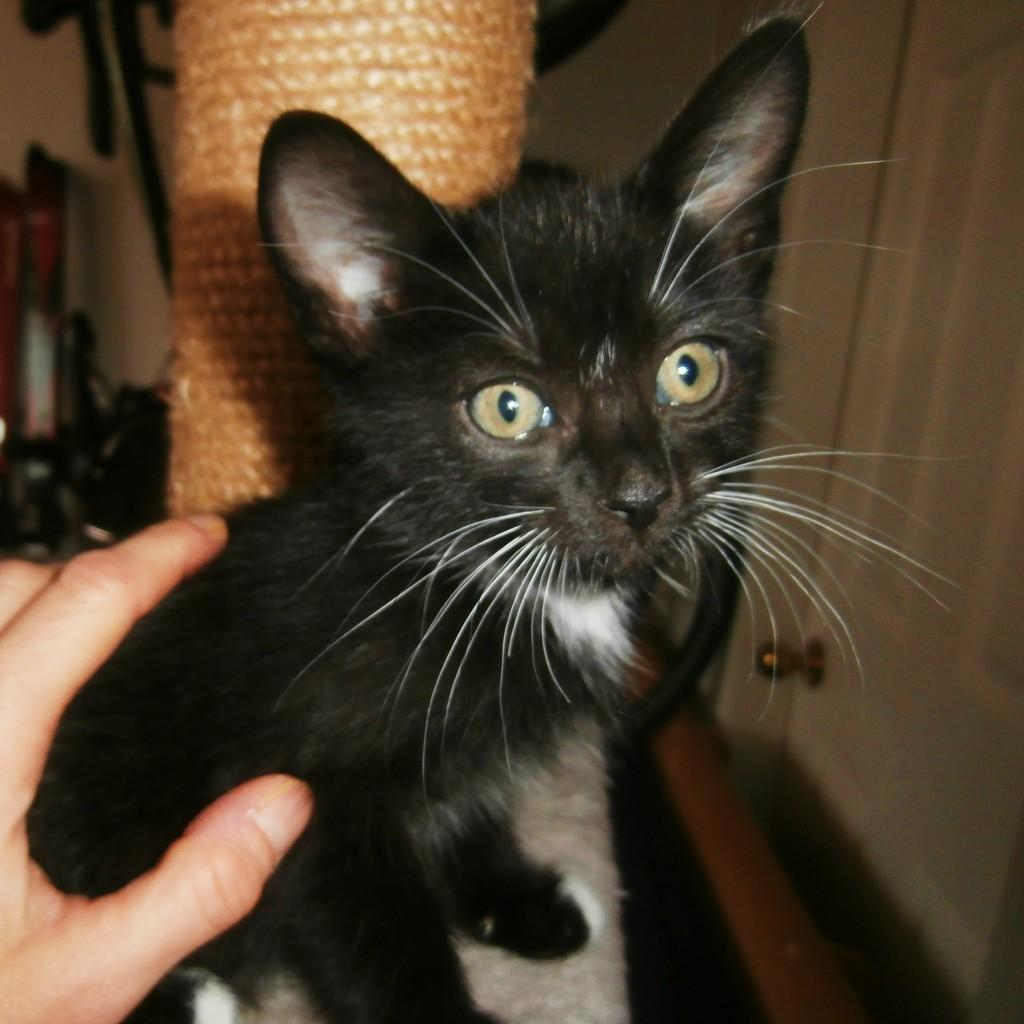What is the main subject in the foreground of the image? There is a cat in the foreground of the image. What else can be seen in the foreground of the image? A person's hand is visible in the foreground of the image. What structures are present in the background of the image? There is a pillar, a wall, and a door in the background of the image. What other objects are present in the background of the image? There are some objects in the background of the image. Can you describe the setting of the image? The image is likely taken in a room. What type of pickle is the cat holding in its paw in the image? There is no pickle present in the image; the cat is not holding anything in its paw. Can you describe the squirrel's behavior in the image? There is no squirrel present in the image. 